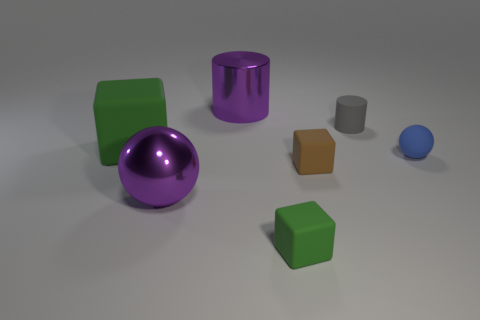What is the material of the tiny brown thing that is the same shape as the big green object?
Provide a short and direct response. Rubber. Are there any other things that are the same material as the big sphere?
Ensure brevity in your answer.  Yes. What number of spheres are either large metal things or tiny gray things?
Give a very brief answer. 1. Does the green thing that is behind the small green matte cube have the same size as the green block to the right of the big green cube?
Offer a terse response. No. The green cube to the left of the purple metallic object behind the big matte thing is made of what material?
Make the answer very short. Rubber. Are there fewer brown matte things in front of the purple metallic cylinder than tiny gray things?
Your answer should be compact. No. There is a blue thing that is made of the same material as the large green object; what is its shape?
Your answer should be compact. Sphere. How many other things are there of the same shape as the tiny brown rubber thing?
Offer a very short reply. 2. What number of gray objects are tiny shiny spheres or big shiny balls?
Offer a very short reply. 0. Do the brown matte object and the large green object have the same shape?
Your response must be concise. Yes. 